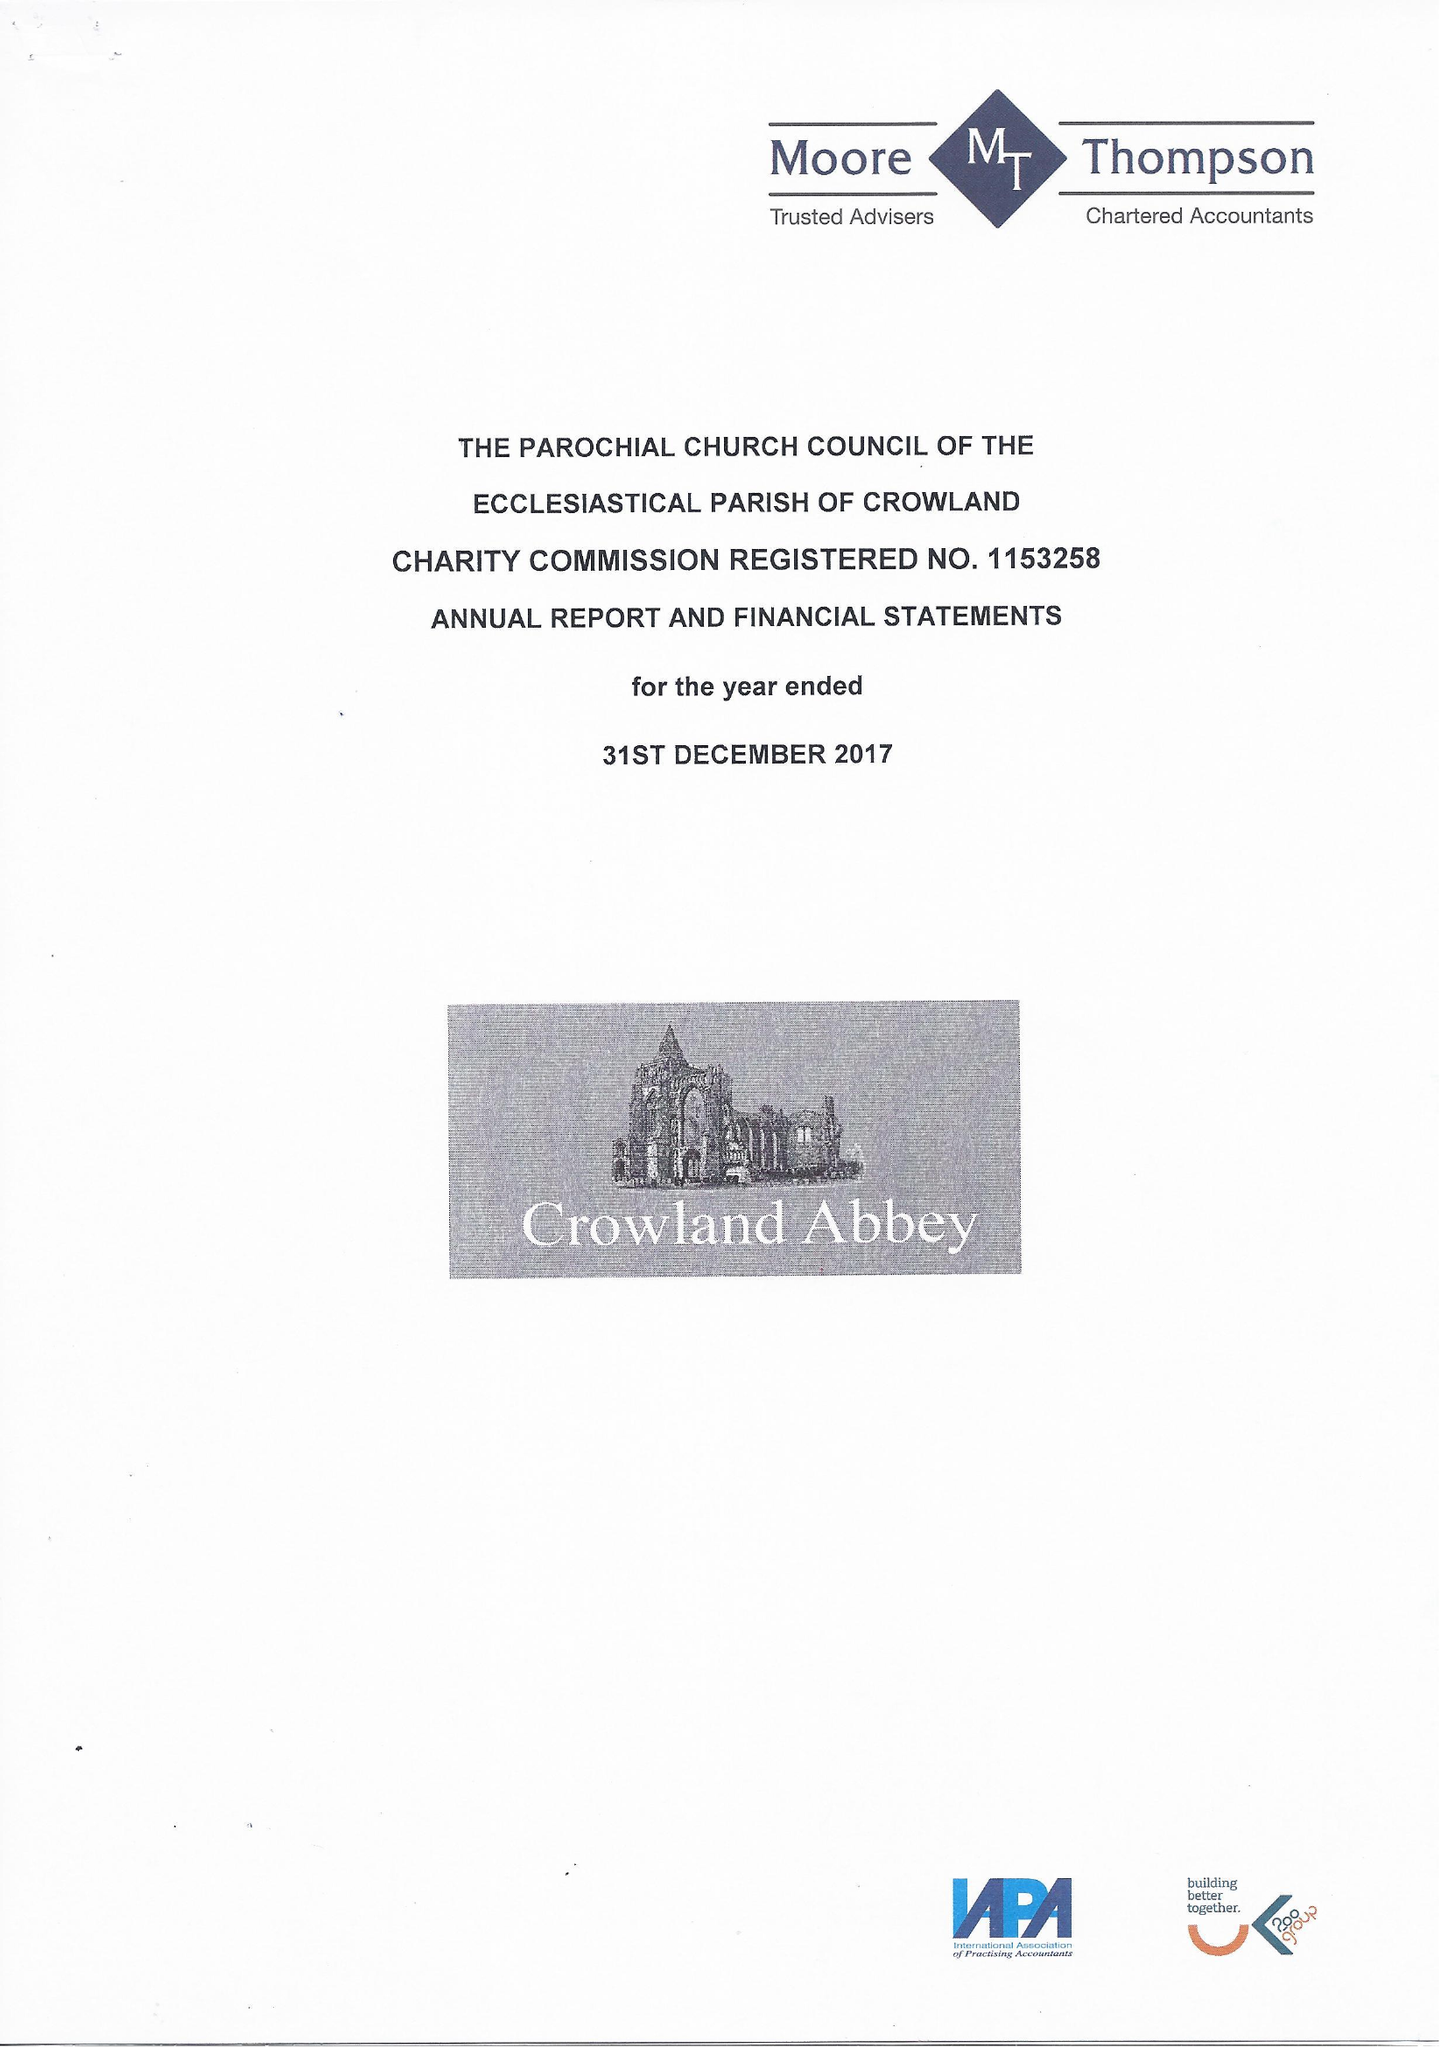What is the value for the charity_number?
Answer the question using a single word or phrase. 1153258 